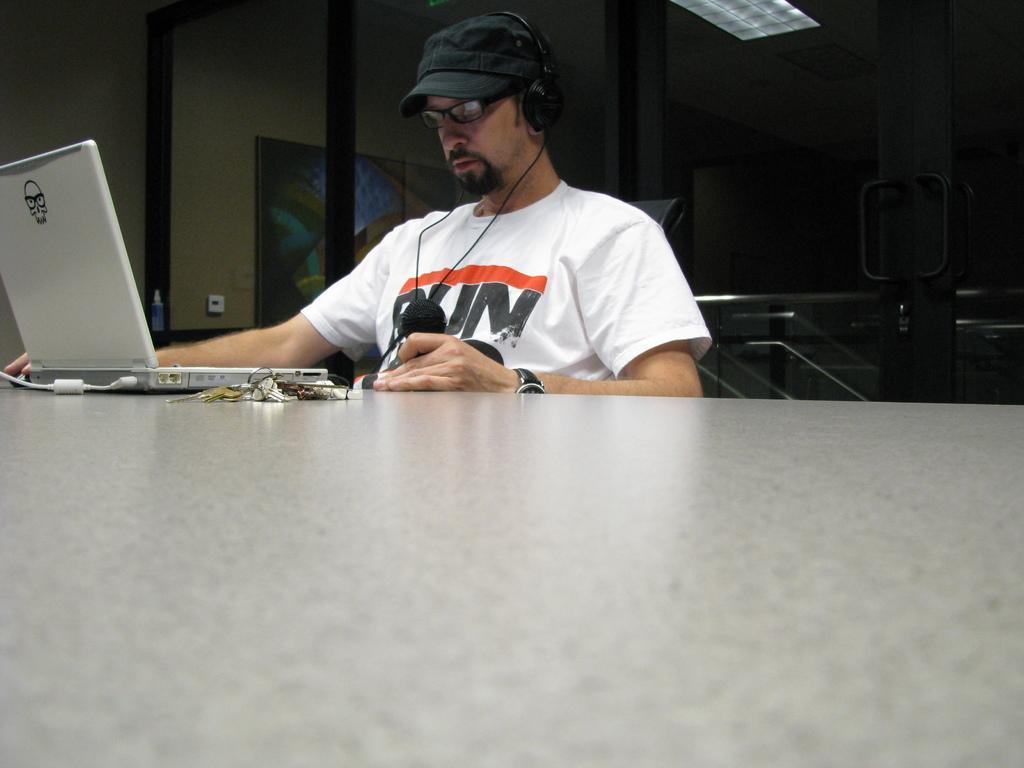Please provide a concise description of this image. In this picture I can see a man seated on the chair and he wore headset and a cap on his head and he wore spectacles and looking at the laptop on the table and I can see reflection of light and a photo frame in the glass. 